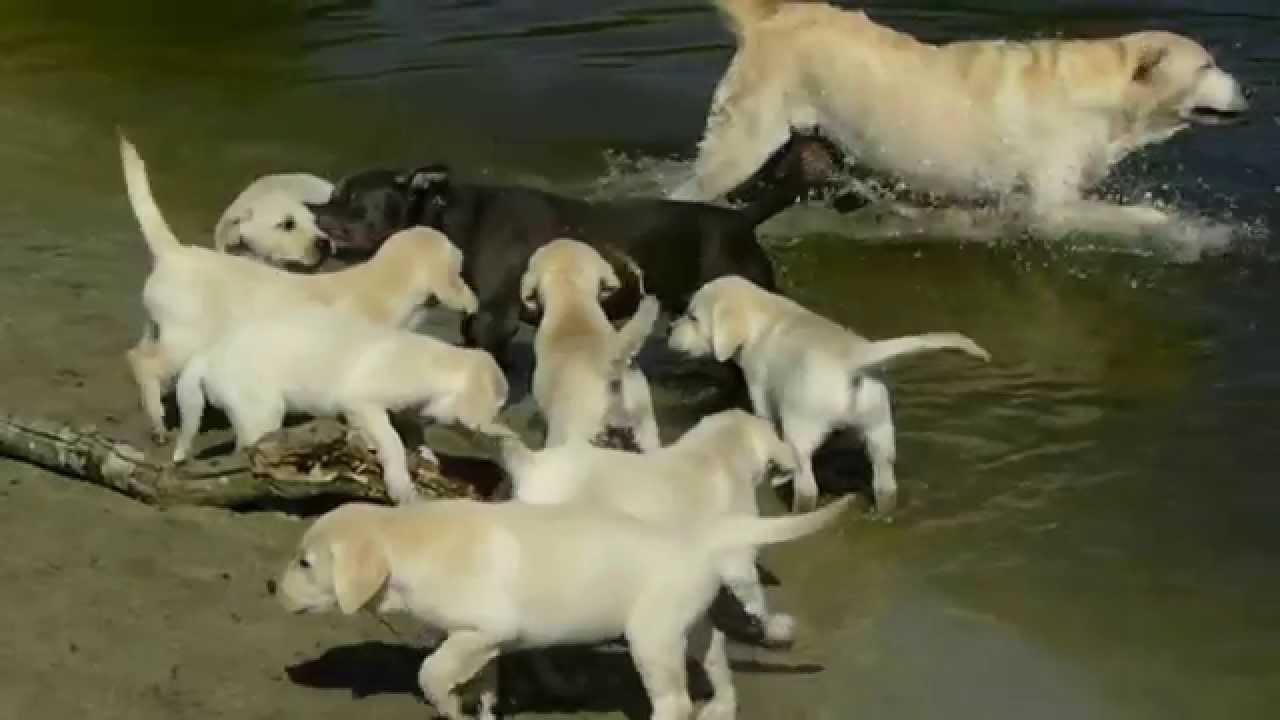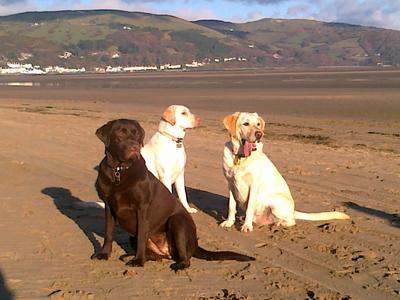The first image is the image on the left, the second image is the image on the right. Given the left and right images, does the statement "An image includes eight nearly white dogs of the same breed." hold true? Answer yes or no. Yes. The first image is the image on the left, the second image is the image on the right. Assess this claim about the two images: "The right image contains exactly three dogs.". Correct or not? Answer yes or no. Yes. 